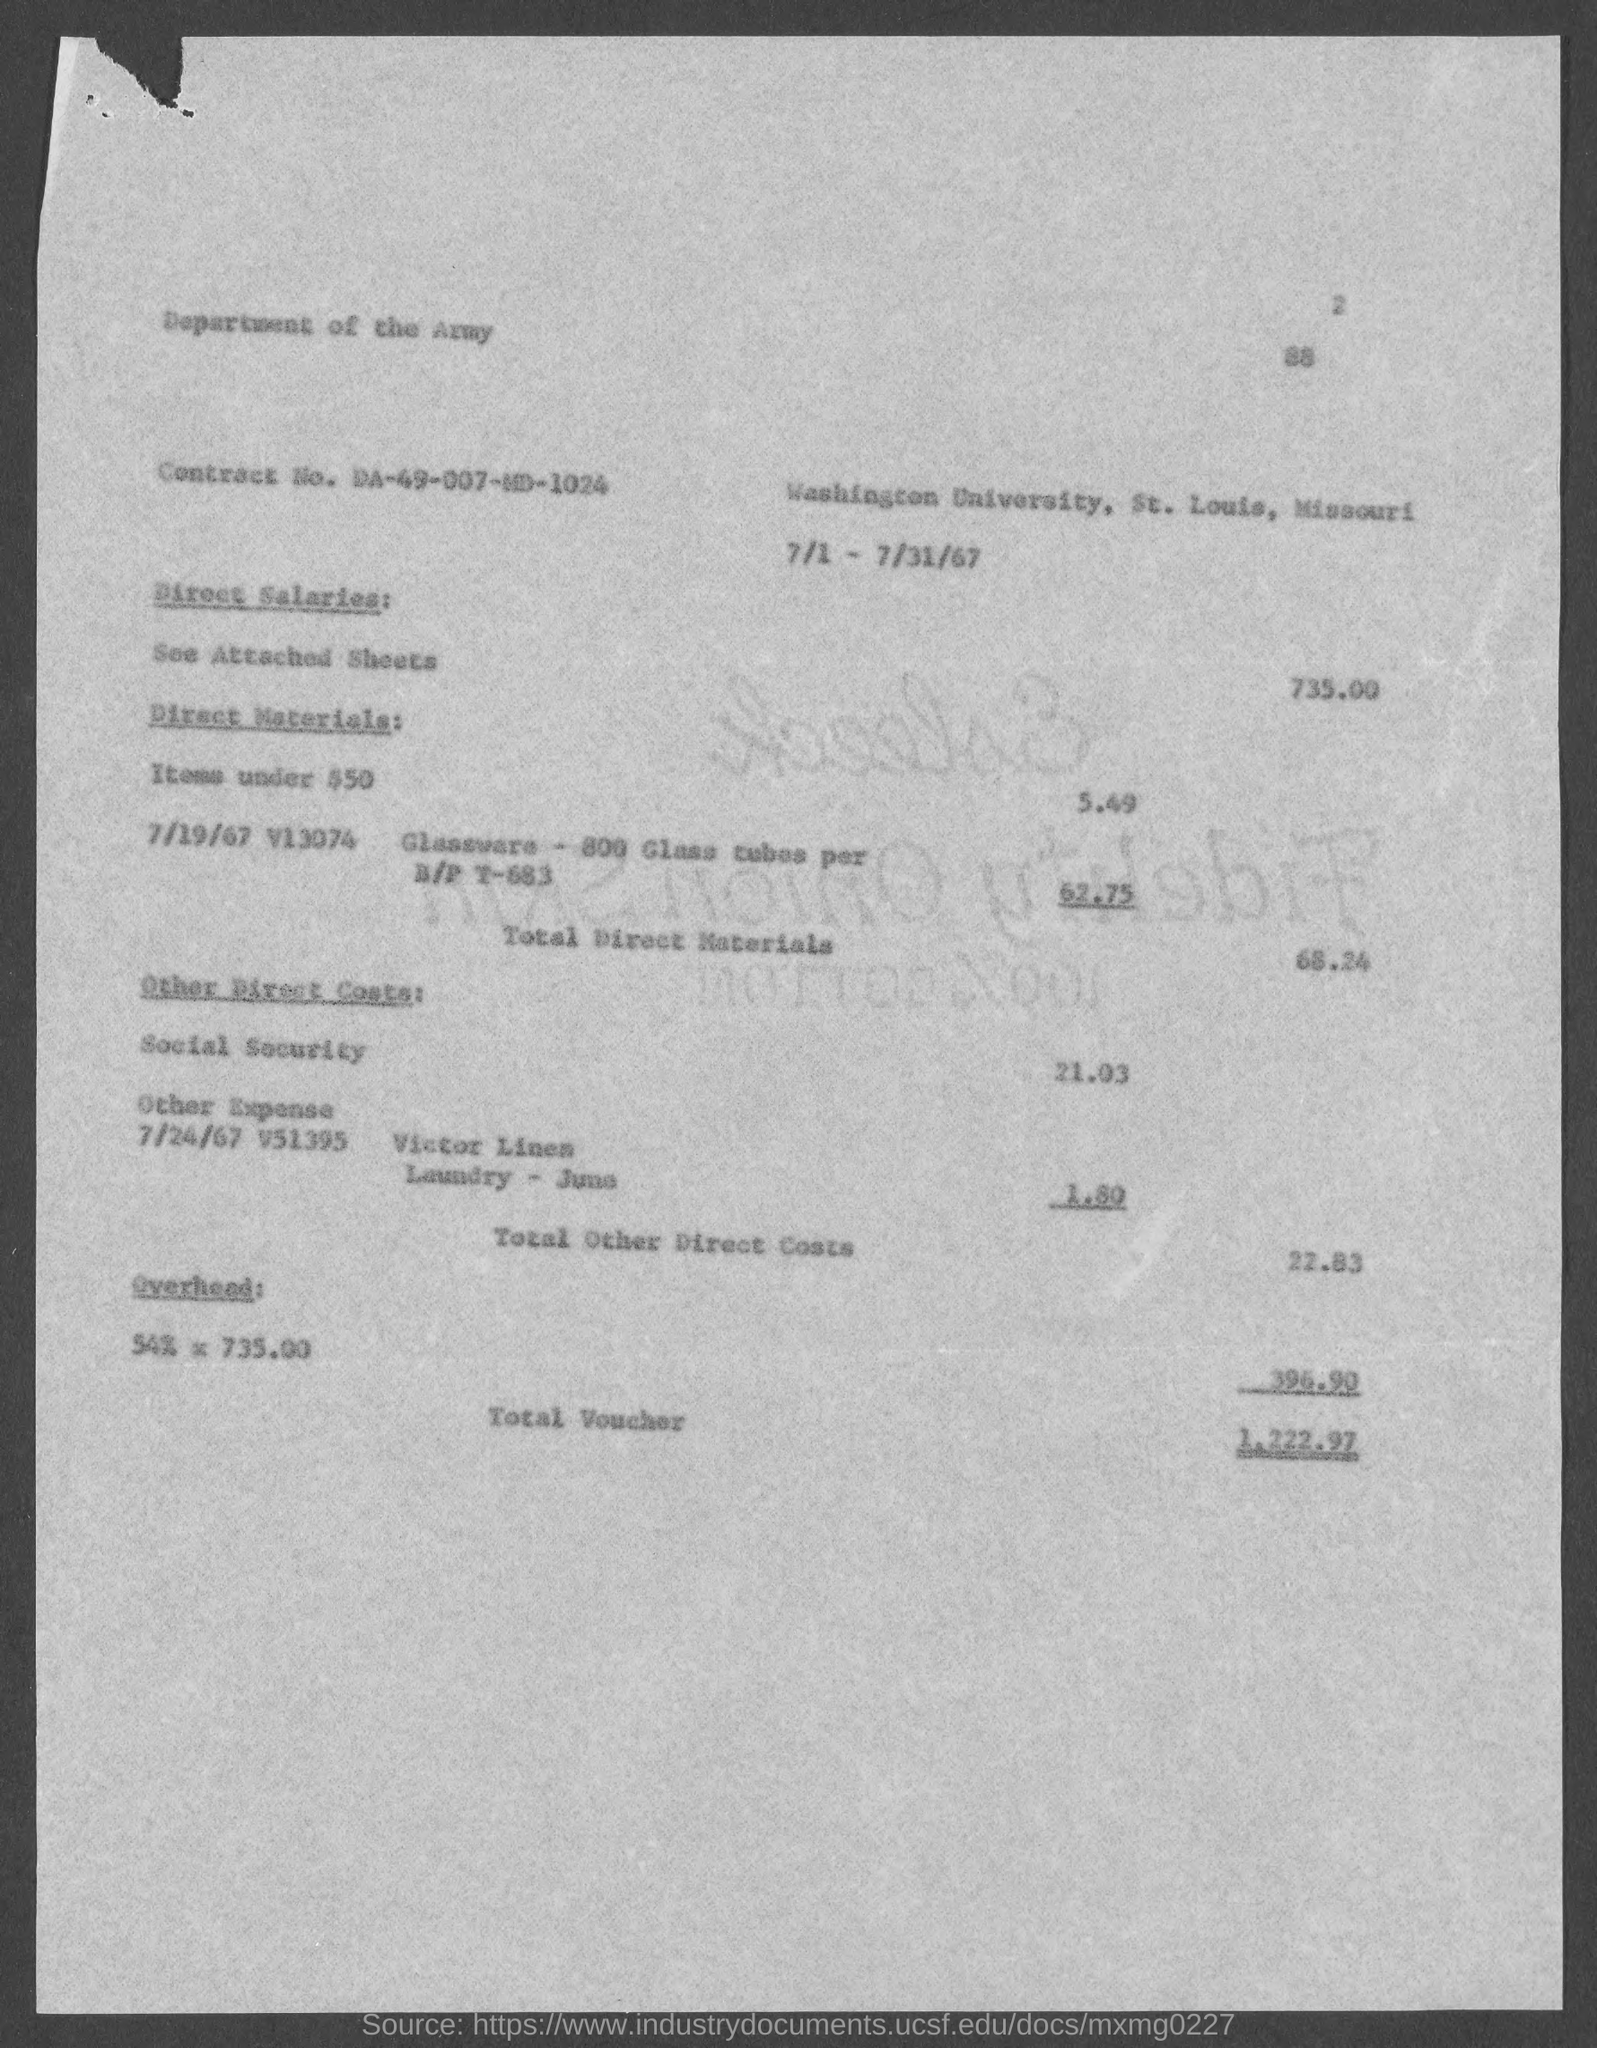What is the total voucher amount mentioned in the document? The document specifies the total voucher amount as $1,222.97, reflecting the cumulative costs associated with the services and materials outlined in the voucher details. 